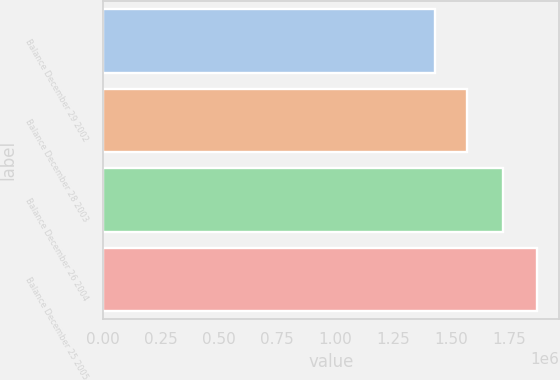Convert chart to OTSL. <chart><loc_0><loc_0><loc_500><loc_500><bar_chart><fcel>Balance December 29 2002<fcel>Balance December 28 2003<fcel>Balance December 26 2004<fcel>Balance December 25 2005<nl><fcel>1.43095e+06<fcel>1.56769e+06<fcel>1.72121e+06<fcel>1.86901e+06<nl></chart> 